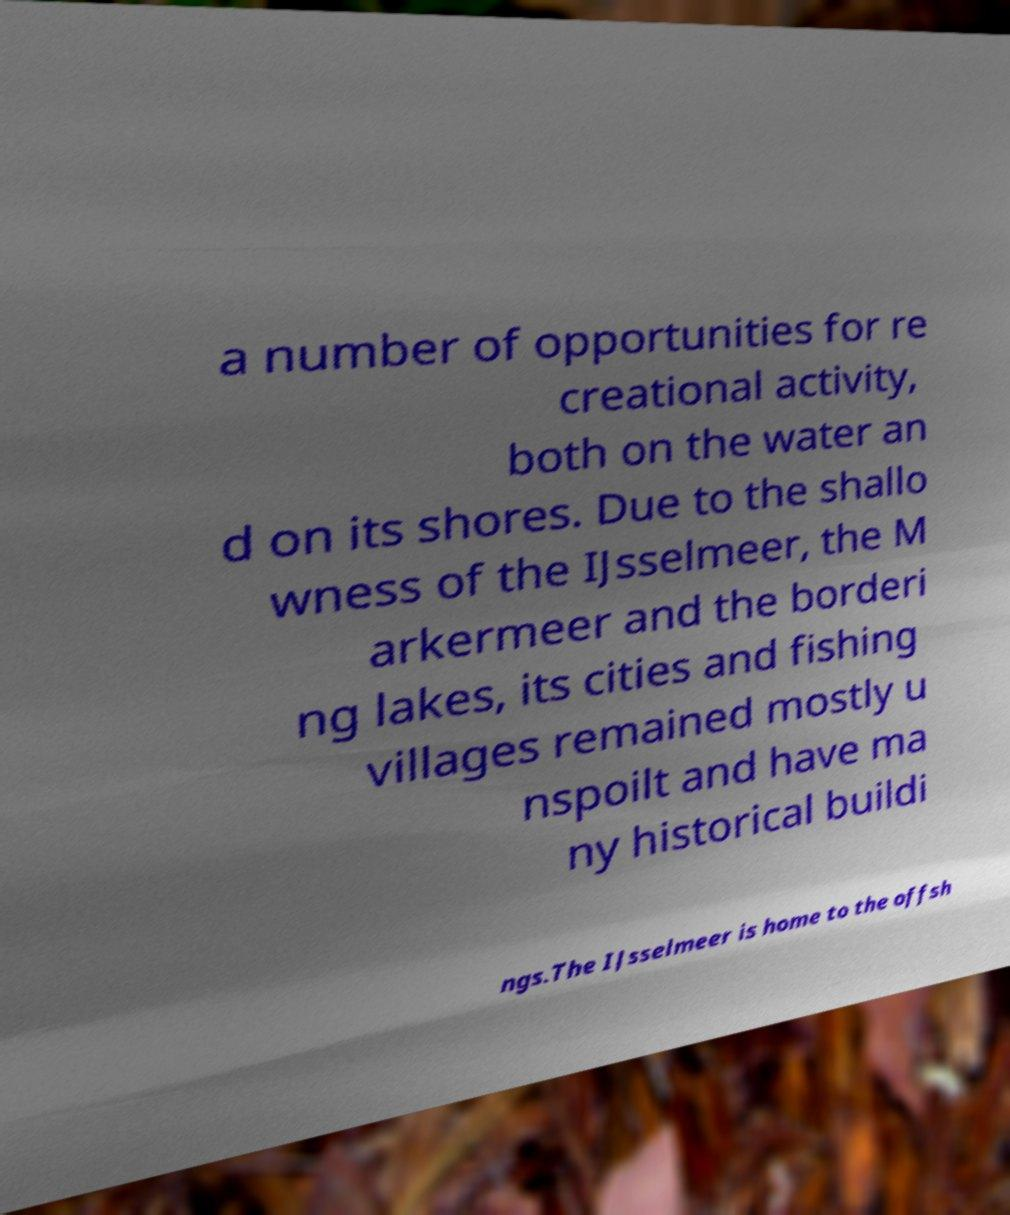Please identify and transcribe the text found in this image. a number of opportunities for re creational activity, both on the water an d on its shores. Due to the shallo wness of the IJsselmeer, the M arkermeer and the borderi ng lakes, its cities and fishing villages remained mostly u nspoilt and have ma ny historical buildi ngs.The IJsselmeer is home to the offsh 